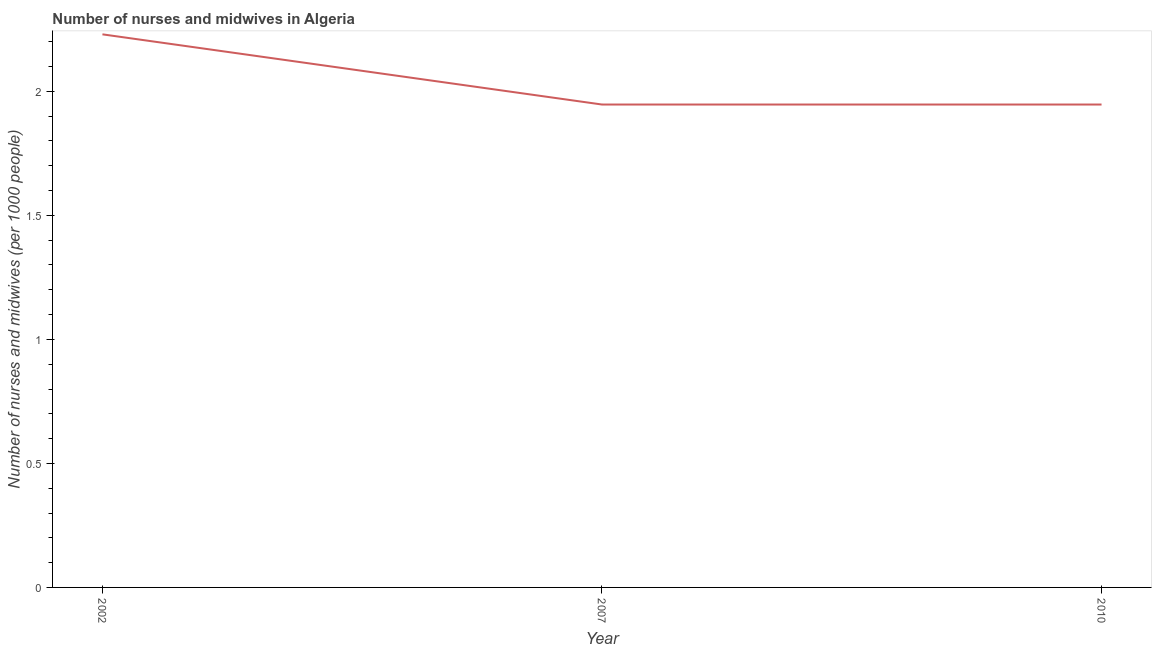What is the number of nurses and midwives in 2007?
Your response must be concise. 1.95. Across all years, what is the maximum number of nurses and midwives?
Provide a short and direct response. 2.23. Across all years, what is the minimum number of nurses and midwives?
Give a very brief answer. 1.95. In which year was the number of nurses and midwives maximum?
Keep it short and to the point. 2002. What is the sum of the number of nurses and midwives?
Your response must be concise. 6.12. What is the difference between the number of nurses and midwives in 2007 and 2010?
Make the answer very short. 0. What is the average number of nurses and midwives per year?
Offer a very short reply. 2.04. What is the median number of nurses and midwives?
Provide a short and direct response. 1.95. In how many years, is the number of nurses and midwives greater than 0.6 ?
Offer a very short reply. 3. Is the number of nurses and midwives in 2002 less than that in 2010?
Provide a succinct answer. No. Is the difference between the number of nurses and midwives in 2007 and 2010 greater than the difference between any two years?
Provide a succinct answer. No. What is the difference between the highest and the second highest number of nurses and midwives?
Your response must be concise. 0.28. What is the difference between the highest and the lowest number of nurses and midwives?
Your answer should be compact. 0.28. In how many years, is the number of nurses and midwives greater than the average number of nurses and midwives taken over all years?
Offer a terse response. 1. Does the number of nurses and midwives monotonically increase over the years?
Your answer should be compact. No. What is the difference between two consecutive major ticks on the Y-axis?
Keep it short and to the point. 0.5. Are the values on the major ticks of Y-axis written in scientific E-notation?
Provide a short and direct response. No. What is the title of the graph?
Provide a succinct answer. Number of nurses and midwives in Algeria. What is the label or title of the X-axis?
Your answer should be compact. Year. What is the label or title of the Y-axis?
Make the answer very short. Number of nurses and midwives (per 1000 people). What is the Number of nurses and midwives (per 1000 people) in 2002?
Your response must be concise. 2.23. What is the Number of nurses and midwives (per 1000 people) in 2007?
Provide a succinct answer. 1.95. What is the Number of nurses and midwives (per 1000 people) of 2010?
Your answer should be very brief. 1.95. What is the difference between the Number of nurses and midwives (per 1000 people) in 2002 and 2007?
Offer a terse response. 0.28. What is the difference between the Number of nurses and midwives (per 1000 people) in 2002 and 2010?
Your response must be concise. 0.28. What is the ratio of the Number of nurses and midwives (per 1000 people) in 2002 to that in 2007?
Keep it short and to the point. 1.15. What is the ratio of the Number of nurses and midwives (per 1000 people) in 2002 to that in 2010?
Your answer should be compact. 1.15. 